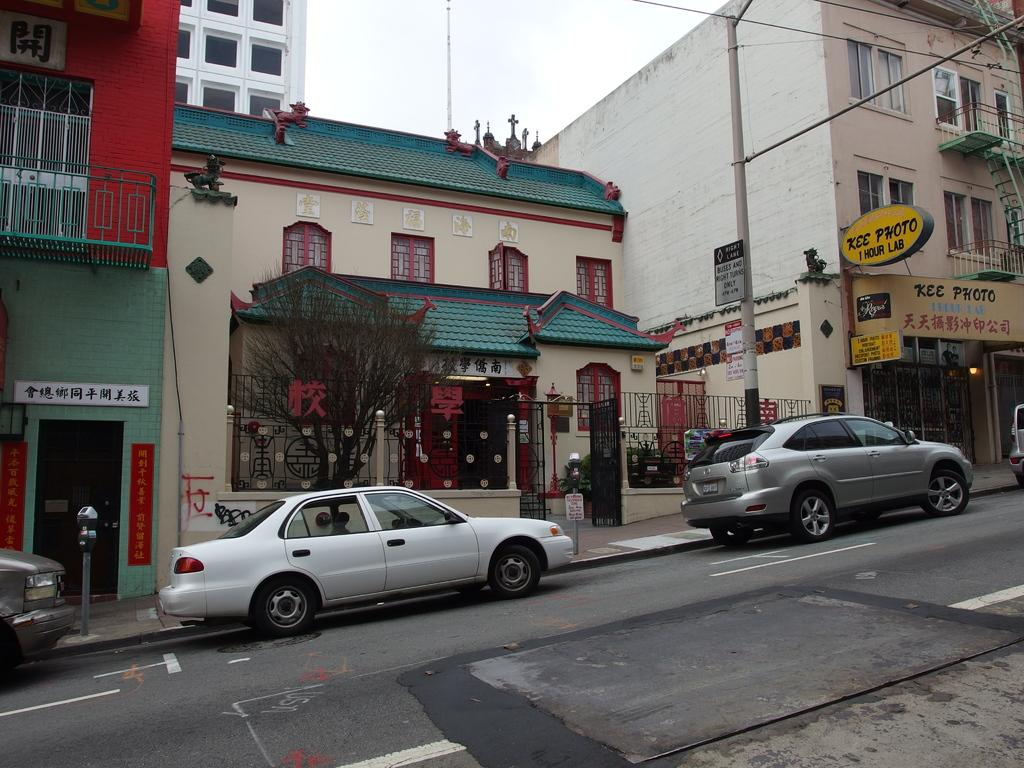What can be seen on the road in the image? There are vehicles on the road in the image. What type of barrier is present in the image? There is a metal grill fence in the image. What structures are visible in the image? There are buildings visible in the image. What architectural feature can be seen in the image? There are metal railing stairs in the image. How many buckets are hanging on the metal railing stairs in the image? There are no buckets present on the metal railing stairs in the image. What type of riddle can be solved by looking at the vehicles on the road in the image? There is no riddle associated with the vehicles on the road in the image. 